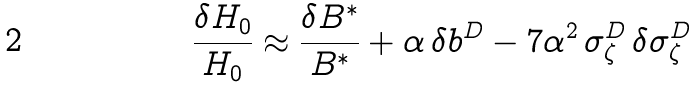<formula> <loc_0><loc_0><loc_500><loc_500>\frac { \delta H _ { 0 } } { H _ { 0 } } \approx \frac { \delta B ^ { * } } { B ^ { * } } + \alpha \, \delta b ^ { D } - { 7 } \alpha ^ { 2 } \, \sigma _ { \zeta } ^ { D } \, \delta \sigma _ { \zeta } ^ { D }</formula> 